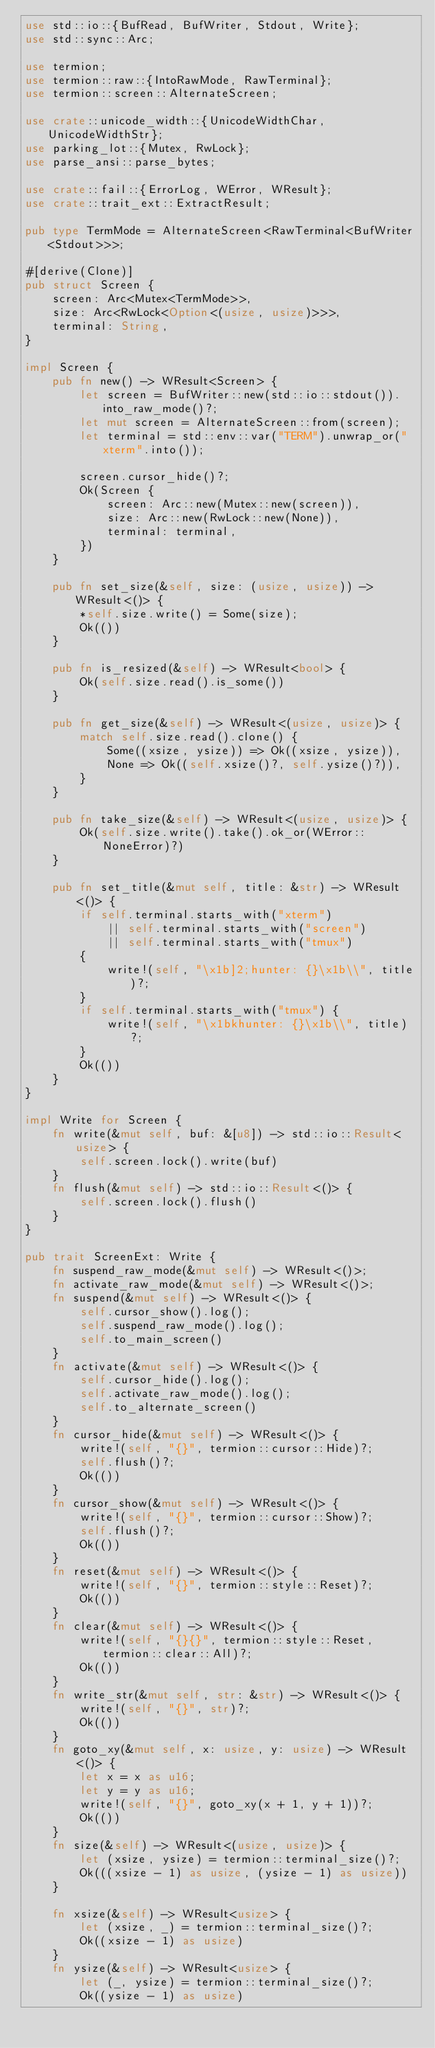Convert code to text. <code><loc_0><loc_0><loc_500><loc_500><_Rust_>use std::io::{BufRead, BufWriter, Stdout, Write};
use std::sync::Arc;

use termion;
use termion::raw::{IntoRawMode, RawTerminal};
use termion::screen::AlternateScreen;

use crate::unicode_width::{UnicodeWidthChar, UnicodeWidthStr};
use parking_lot::{Mutex, RwLock};
use parse_ansi::parse_bytes;

use crate::fail::{ErrorLog, WError, WResult};
use crate::trait_ext::ExtractResult;

pub type TermMode = AlternateScreen<RawTerminal<BufWriter<Stdout>>>;

#[derive(Clone)]
pub struct Screen {
    screen: Arc<Mutex<TermMode>>,
    size: Arc<RwLock<Option<(usize, usize)>>>,
    terminal: String,
}

impl Screen {
    pub fn new() -> WResult<Screen> {
        let screen = BufWriter::new(std::io::stdout()).into_raw_mode()?;
        let mut screen = AlternateScreen::from(screen);
        let terminal = std::env::var("TERM").unwrap_or("xterm".into());

        screen.cursor_hide()?;
        Ok(Screen {
            screen: Arc::new(Mutex::new(screen)),
            size: Arc::new(RwLock::new(None)),
            terminal: terminal,
        })
    }

    pub fn set_size(&self, size: (usize, usize)) -> WResult<()> {
        *self.size.write() = Some(size);
        Ok(())
    }

    pub fn is_resized(&self) -> WResult<bool> {
        Ok(self.size.read().is_some())
    }

    pub fn get_size(&self) -> WResult<(usize, usize)> {
        match self.size.read().clone() {
            Some((xsize, ysize)) => Ok((xsize, ysize)),
            None => Ok((self.xsize()?, self.ysize()?)),
        }
    }

    pub fn take_size(&self) -> WResult<(usize, usize)> {
        Ok(self.size.write().take().ok_or(WError::NoneError)?)
    }

    pub fn set_title(&mut self, title: &str) -> WResult<()> {
        if self.terminal.starts_with("xterm")
            || self.terminal.starts_with("screen")
            || self.terminal.starts_with("tmux")
        {
            write!(self, "\x1b]2;hunter: {}\x1b\\", title)?;
        }
        if self.terminal.starts_with("tmux") {
            write!(self, "\x1bkhunter: {}\x1b\\", title)?;
        }
        Ok(())
    }
}

impl Write for Screen {
    fn write(&mut self, buf: &[u8]) -> std::io::Result<usize> {
        self.screen.lock().write(buf)
    }
    fn flush(&mut self) -> std::io::Result<()> {
        self.screen.lock().flush()
    }
}

pub trait ScreenExt: Write {
    fn suspend_raw_mode(&mut self) -> WResult<()>;
    fn activate_raw_mode(&mut self) -> WResult<()>;
    fn suspend(&mut self) -> WResult<()> {
        self.cursor_show().log();
        self.suspend_raw_mode().log();
        self.to_main_screen()
    }
    fn activate(&mut self) -> WResult<()> {
        self.cursor_hide().log();
        self.activate_raw_mode().log();
        self.to_alternate_screen()
    }
    fn cursor_hide(&mut self) -> WResult<()> {
        write!(self, "{}", termion::cursor::Hide)?;
        self.flush()?;
        Ok(())
    }
    fn cursor_show(&mut self) -> WResult<()> {
        write!(self, "{}", termion::cursor::Show)?;
        self.flush()?;
        Ok(())
    }
    fn reset(&mut self) -> WResult<()> {
        write!(self, "{}", termion::style::Reset)?;
        Ok(())
    }
    fn clear(&mut self) -> WResult<()> {
        write!(self, "{}{}", termion::style::Reset, termion::clear::All)?;
        Ok(())
    }
    fn write_str(&mut self, str: &str) -> WResult<()> {
        write!(self, "{}", str)?;
        Ok(())
    }
    fn goto_xy(&mut self, x: usize, y: usize) -> WResult<()> {
        let x = x as u16;
        let y = y as u16;
        write!(self, "{}", goto_xy(x + 1, y + 1))?;
        Ok(())
    }
    fn size(&self) -> WResult<(usize, usize)> {
        let (xsize, ysize) = termion::terminal_size()?;
        Ok(((xsize - 1) as usize, (ysize - 1) as usize))
    }

    fn xsize(&self) -> WResult<usize> {
        let (xsize, _) = termion::terminal_size()?;
        Ok((xsize - 1) as usize)
    }
    fn ysize(&self) -> WResult<usize> {
        let (_, ysize) = termion::terminal_size()?;
        Ok((ysize - 1) as usize)</code> 